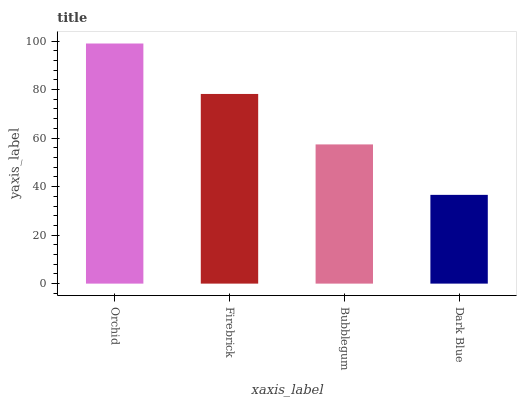Is Dark Blue the minimum?
Answer yes or no. Yes. Is Orchid the maximum?
Answer yes or no. Yes. Is Firebrick the minimum?
Answer yes or no. No. Is Firebrick the maximum?
Answer yes or no. No. Is Orchid greater than Firebrick?
Answer yes or no. Yes. Is Firebrick less than Orchid?
Answer yes or no. Yes. Is Firebrick greater than Orchid?
Answer yes or no. No. Is Orchid less than Firebrick?
Answer yes or no. No. Is Firebrick the high median?
Answer yes or no. Yes. Is Bubblegum the low median?
Answer yes or no. Yes. Is Orchid the high median?
Answer yes or no. No. Is Orchid the low median?
Answer yes or no. No. 